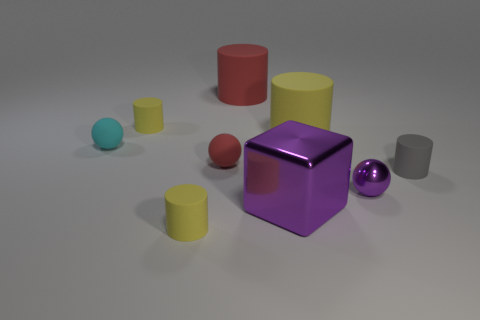Subtract all red matte cylinders. How many cylinders are left? 4 Subtract all gray cylinders. How many cylinders are left? 4 Subtract all red spheres. How many yellow cylinders are left? 3 Subtract all balls. How many objects are left? 6 Subtract 1 blocks. How many blocks are left? 0 Subtract all cyan balls. Subtract all brown cylinders. How many balls are left? 2 Subtract all red matte cylinders. Subtract all yellow matte cylinders. How many objects are left? 5 Add 4 red rubber balls. How many red rubber balls are left? 5 Add 9 small cyan spheres. How many small cyan spheres exist? 10 Subtract 0 green cylinders. How many objects are left? 9 